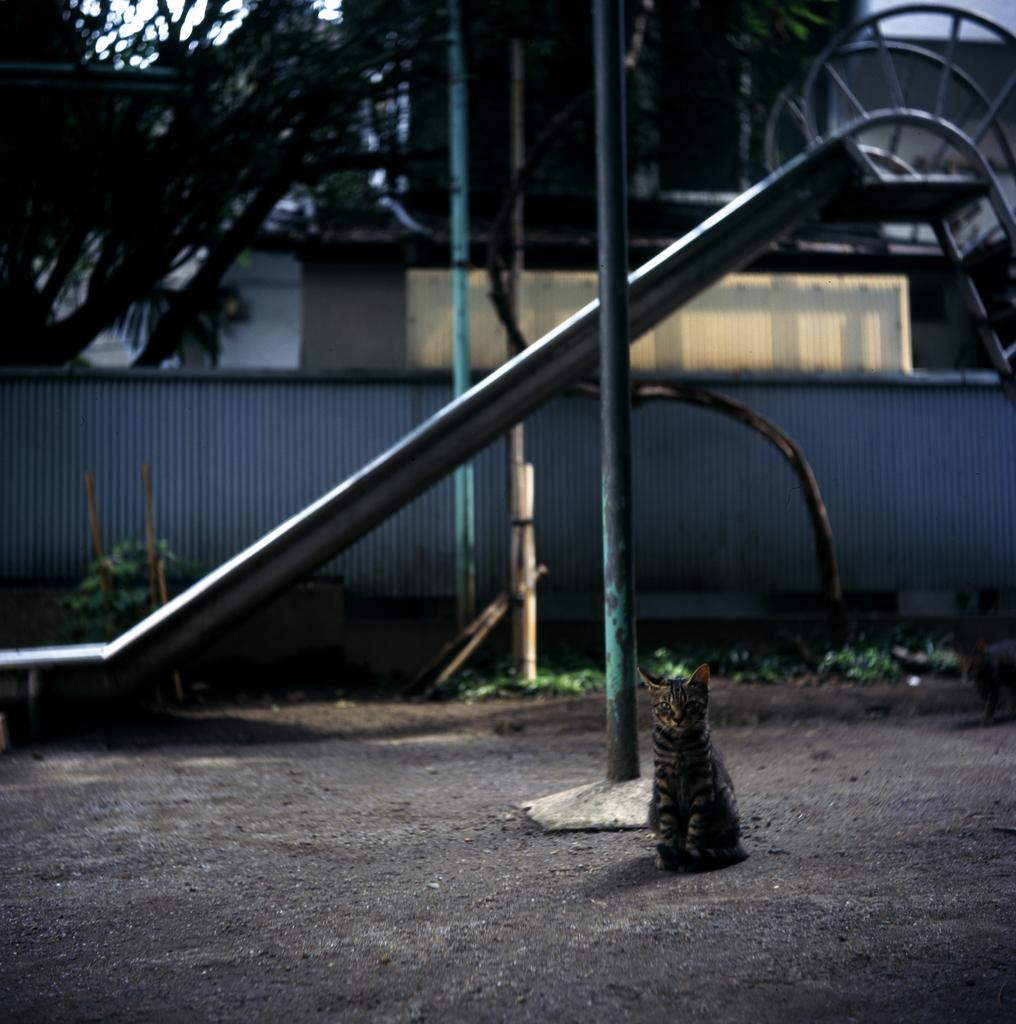What type of playground equipment is present in the image? There is a slide in the image. What else can be seen in the image besides the slide? There is a wall, plants, a cat on the ground, and trees visible in the background of the image. How many mice are playing on the cat's knee in the image? There are no mice present in the image, and the cat's knee is not visible. 